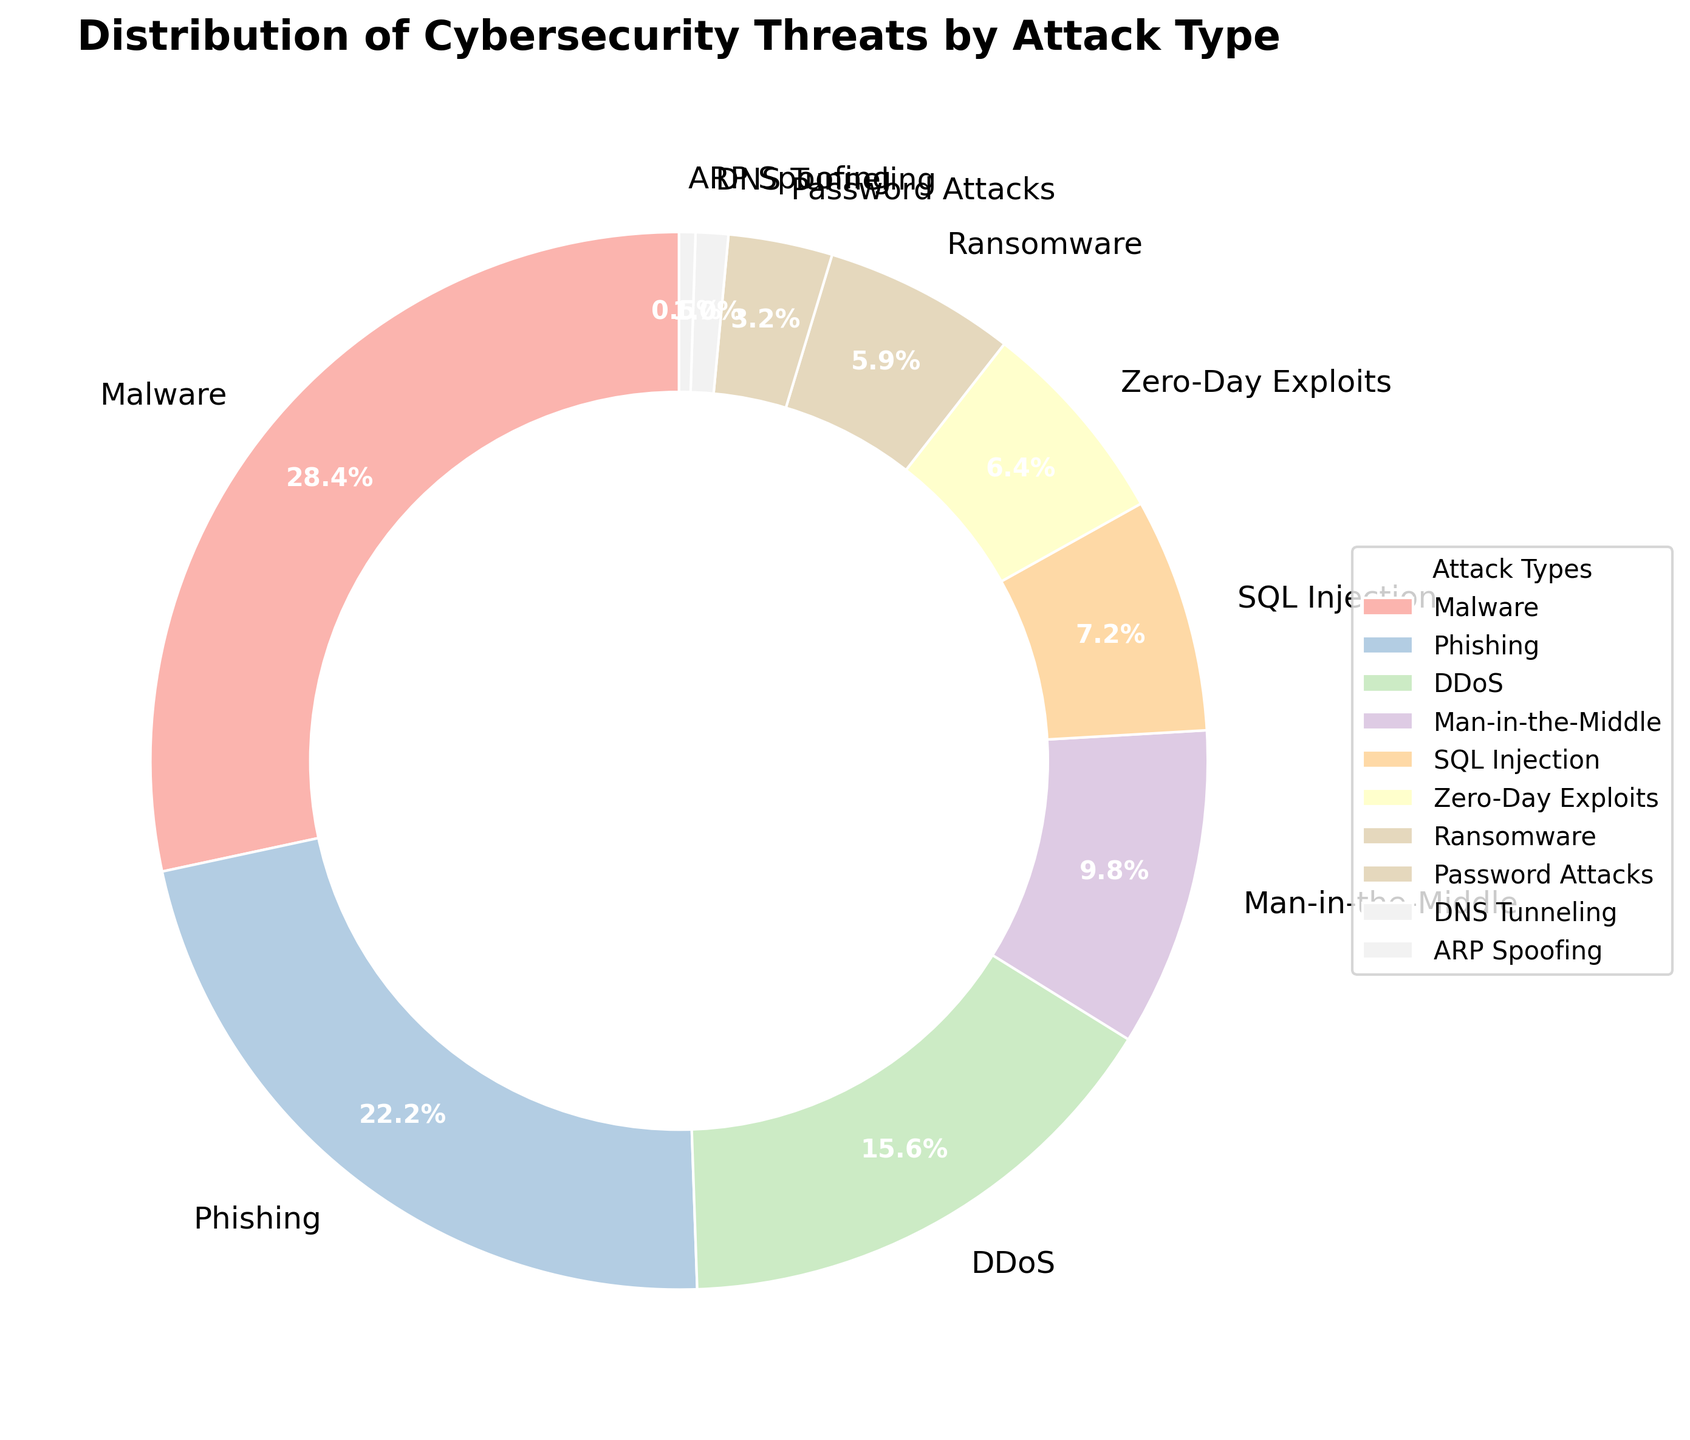What attack type has the highest percentage? The figure shows various attack types with their respective percentages. The attack type with the largest section of the pie chart is Malware, which occupies 28.5% of the chart.
Answer: Malware What is the combined percentage of Malware and Phishing attacks? The percentages for Malware and Phishing are 28.5% and 22.3% respectively. Adding them together gives 28.5 + 22.3 = 50.8%.
Answer: 50.8% Which attack type accounts for less than 1% of the total cybersecurity threats? The attack types with percentages less than 1% on the pie chart are DNS Tunneling (1.0%) and ARP Spoofing (0.5%). Only ARP Spoofing is less than 1%.
Answer: ARP Spoofing How does the percentage of DDoS attacks compare to the percentage of Man-in-the-Middle attacks? The percentage of DDoS attacks is 15.7%, while the percentage of Man-in-the-Middle attacks is 9.8%. DDoS attacks have a higher percentage.
Answer: DDoS has a higher percentage Which two attack types have the smallest percentages, and what is their combined total? The smallest percentages on the chart are for DNS Tunneling (1.0%) and ARP Spoofing (0.5%). Adding these together gives 1.0 + 0.5 = 1.5%.
Answer: DNS Tunneling and ARP Spoofing, 1.5% What is the percentage difference between Ransomware and Password Attacks? Ransomware accounts for 5.9% and Password Attacks for 3.2%. The difference is 5.9 - 3.2 = 2.7%.
Answer: 2.7% What is the total percentage for SQL Injection and Zero-Day Exploits combined? The figure shows 7.2% for SQL Injection and 6.4% for Zero-Day Exploits. The combined total is 7.2 + 6.4 = 13.6%.
Answer: 13.6% Approximately what fraction of the total threats is constituted by Man-in-the-Middle and Password Attacks combined? Man-in-the-Middle accounts for 9.8% and Password Attacks for 3.2%. Their combined percentage is 9.8 + 3.2 = 13.0%. Dividing by 100 gives 13.0/100 = 0.13, which is approximately 1/8.
Answer: 1/8 Which color represents Malware on the pie chart? The exact colors are not specified in terms of names, but Malware has the largest sector. Hence, refer to the pie chart and identify the color of the largest section.
Answer: The color of the largest section 